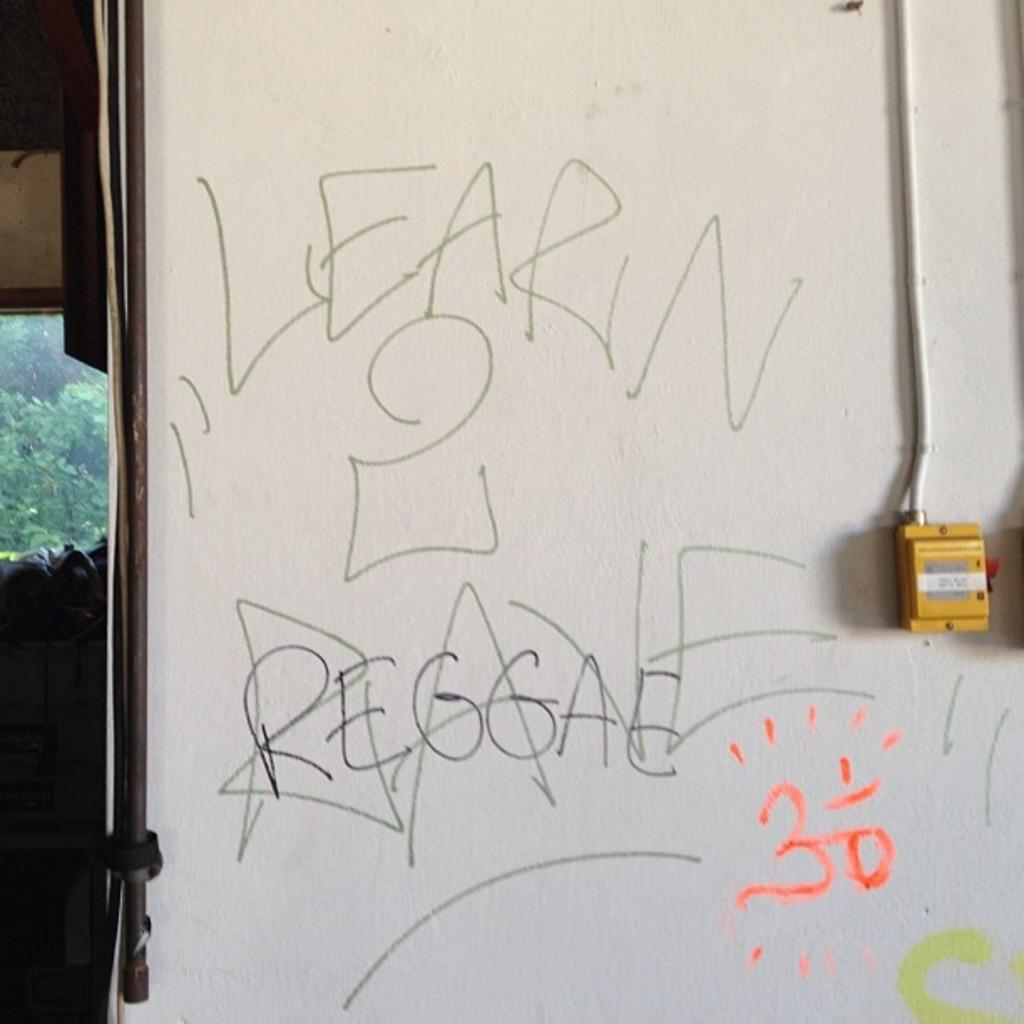What is present on the wall in the image? There are words on the wall in the image. Can you describe the background of the image? There are trees in the background of the image. What is the cause of the church's collapse in the image? There is no church or any indication of a collapse in the image. 